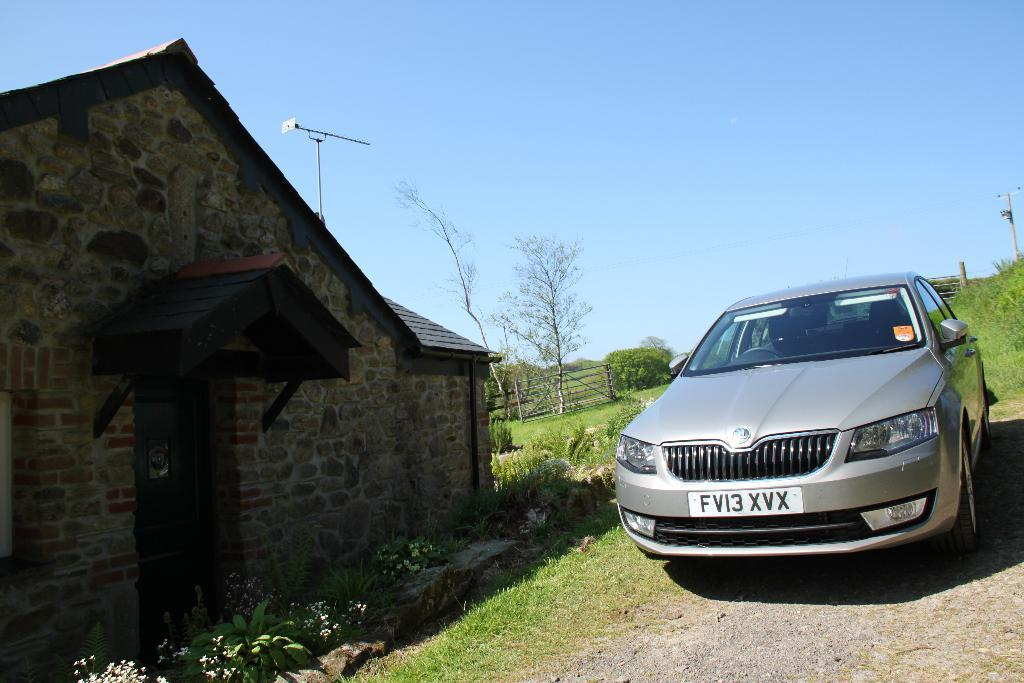What can be seen on the right side of the image? On the right side of the image, there is a car, plants, a current pole, grass, and soil. What is present on the left side of the image? On the left side of the image, there are plants, flowers, trees, fencing, a house, and a pole. What is the weather like in the image? The sky is sunny in the image. Can you tell me how many pets are visible in the image? There are no pets present in the image. What type of box can be seen on the left side of the image? There is no box present on the left side of the image. 